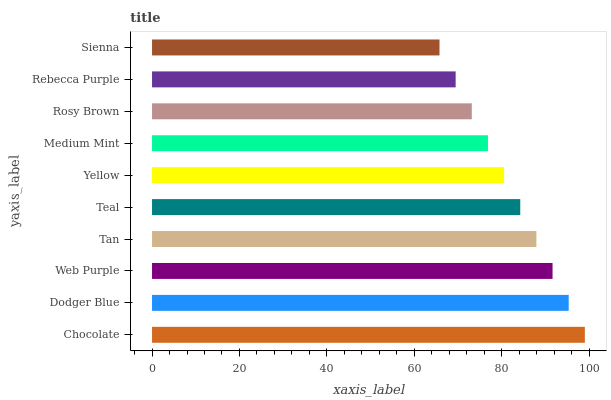Is Sienna the minimum?
Answer yes or no. Yes. Is Chocolate the maximum?
Answer yes or no. Yes. Is Dodger Blue the minimum?
Answer yes or no. No. Is Dodger Blue the maximum?
Answer yes or no. No. Is Chocolate greater than Dodger Blue?
Answer yes or no. Yes. Is Dodger Blue less than Chocolate?
Answer yes or no. Yes. Is Dodger Blue greater than Chocolate?
Answer yes or no. No. Is Chocolate less than Dodger Blue?
Answer yes or no. No. Is Teal the high median?
Answer yes or no. Yes. Is Yellow the low median?
Answer yes or no. Yes. Is Yellow the high median?
Answer yes or no. No. Is Rosy Brown the low median?
Answer yes or no. No. 